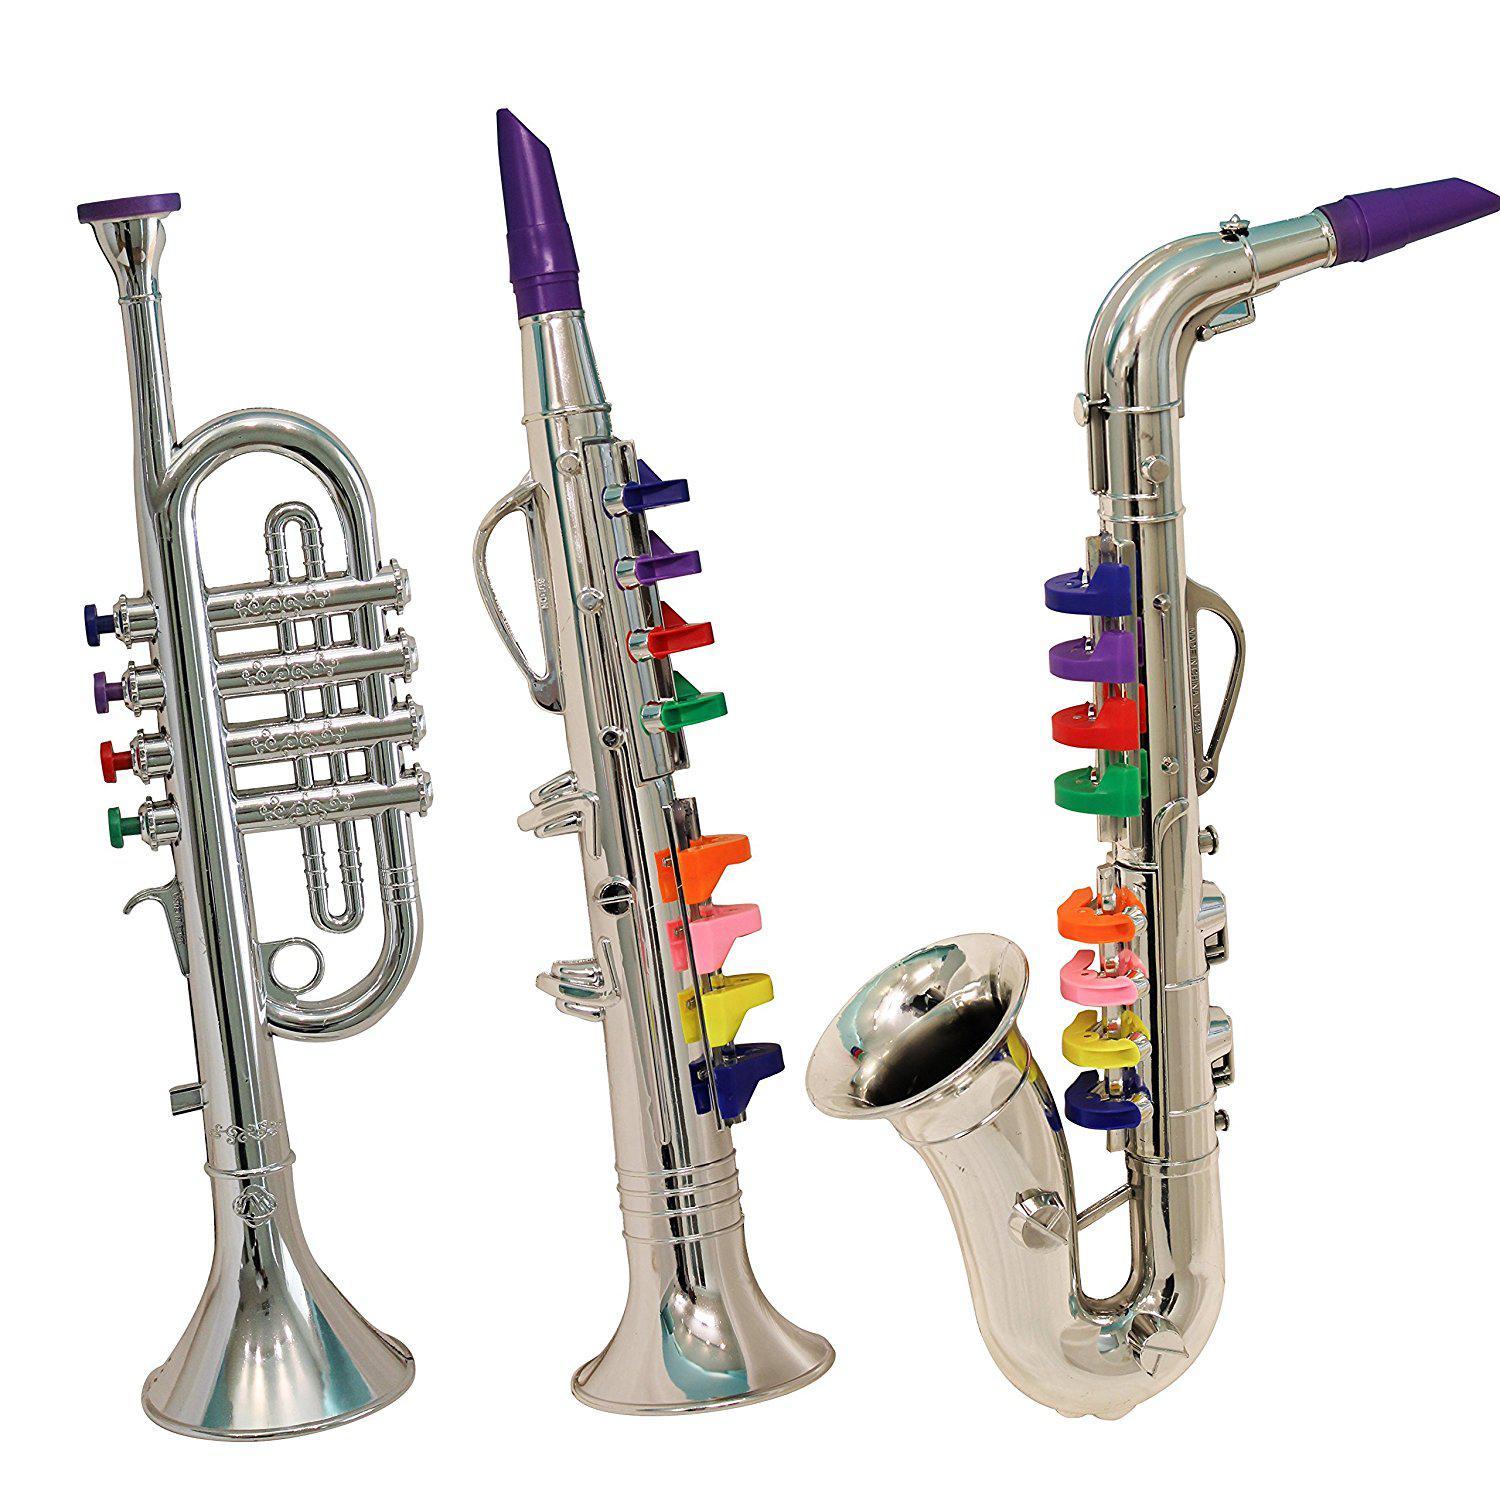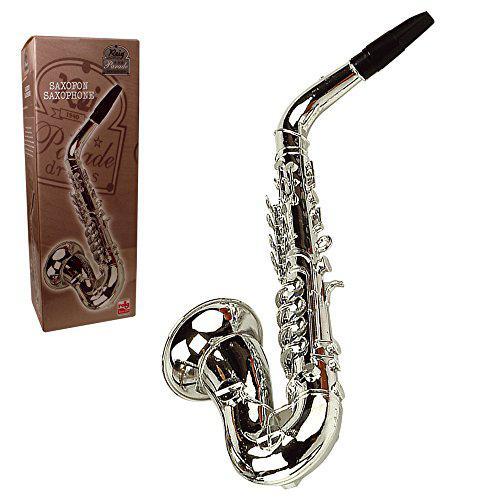The first image is the image on the left, the second image is the image on the right. Given the left and right images, does the statement "In one of the images there is a child playing a saxophone." hold true? Answer yes or no. No. The first image is the image on the left, the second image is the image on the right. Analyze the images presented: Is the assertion "In one image, a child wearing jeans is leaning back as he or she plays a saxophone." valid? Answer yes or no. No. 